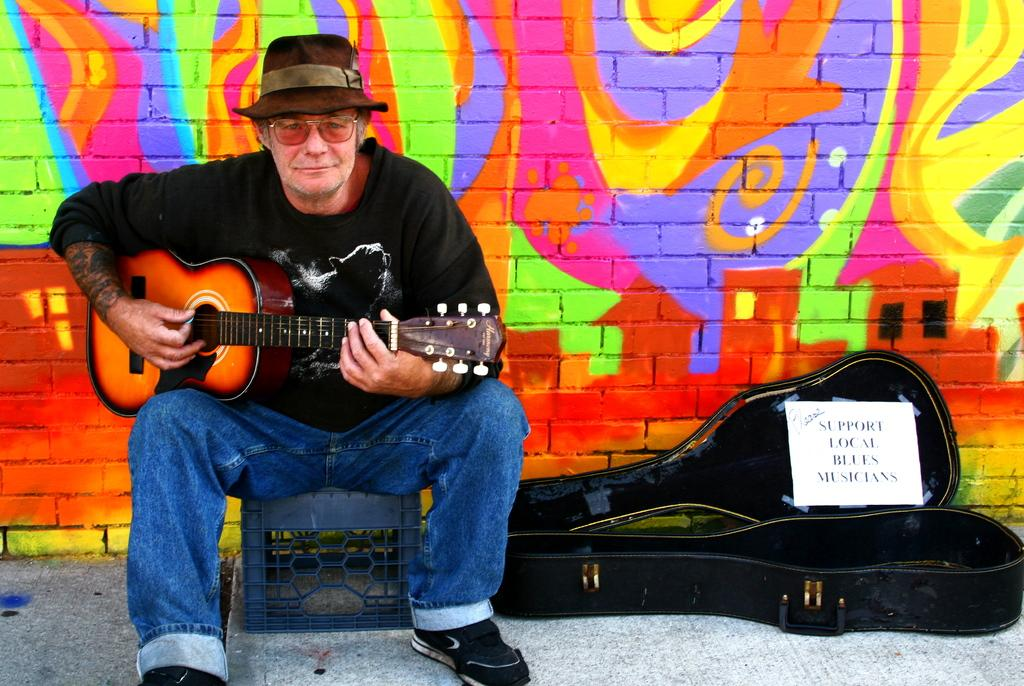Who is present in the image? There is a person in the image. What is the person holding in the image? The person is holding a guitar. What else can be seen near the person? There is a guitar bag beside the person. What is the rate of the land visible in the image? There is no land visible in the image, so it is not possible to determine the rate of the land. 